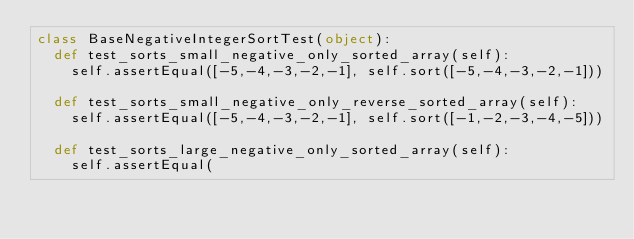Convert code to text. <code><loc_0><loc_0><loc_500><loc_500><_Python_>class BaseNegativeIntegerSortTest(object):
  def test_sorts_small_negative_only_sorted_array(self):
    self.assertEqual([-5,-4,-3,-2,-1], self.sort([-5,-4,-3,-2,-1]))

  def test_sorts_small_negative_only_reverse_sorted_array(self):
    self.assertEqual([-5,-4,-3,-2,-1], self.sort([-1,-2,-3,-4,-5]))

  def test_sorts_large_negative_only_sorted_array(self):
    self.assertEqual(</code> 